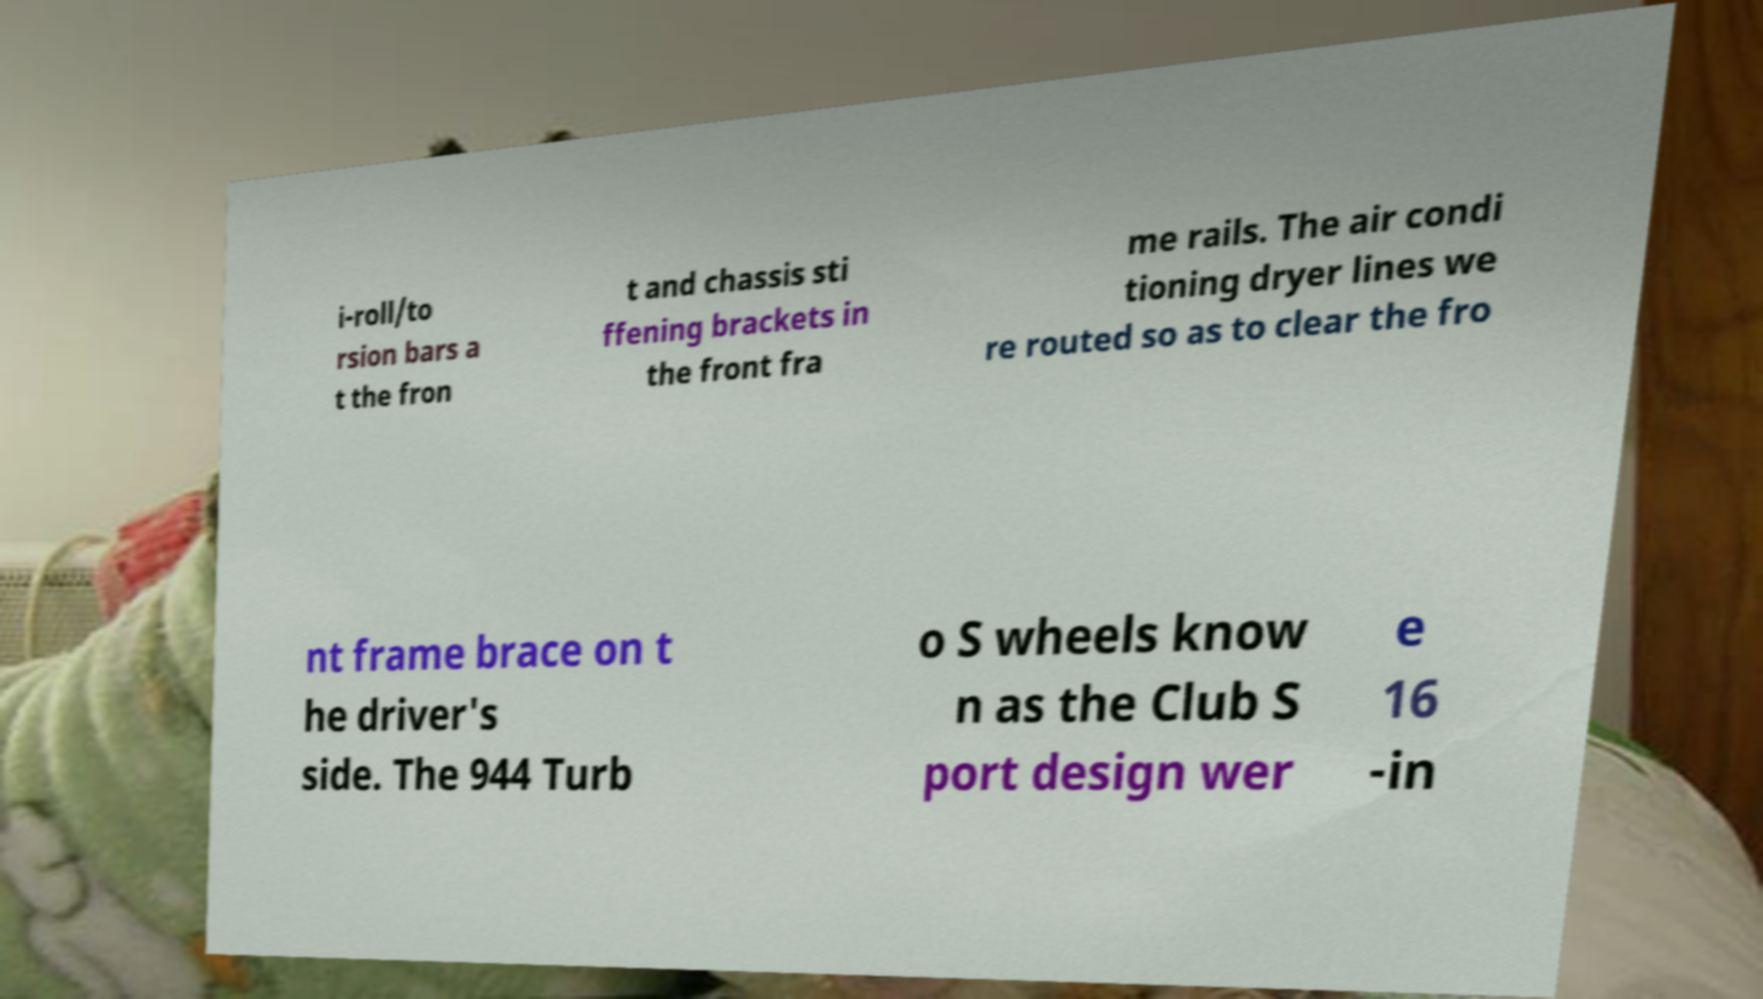For documentation purposes, I need the text within this image transcribed. Could you provide that? i-roll/to rsion bars a t the fron t and chassis sti ffening brackets in the front fra me rails. The air condi tioning dryer lines we re routed so as to clear the fro nt frame brace on t he driver's side. The 944 Turb o S wheels know n as the Club S port design wer e 16 -in 